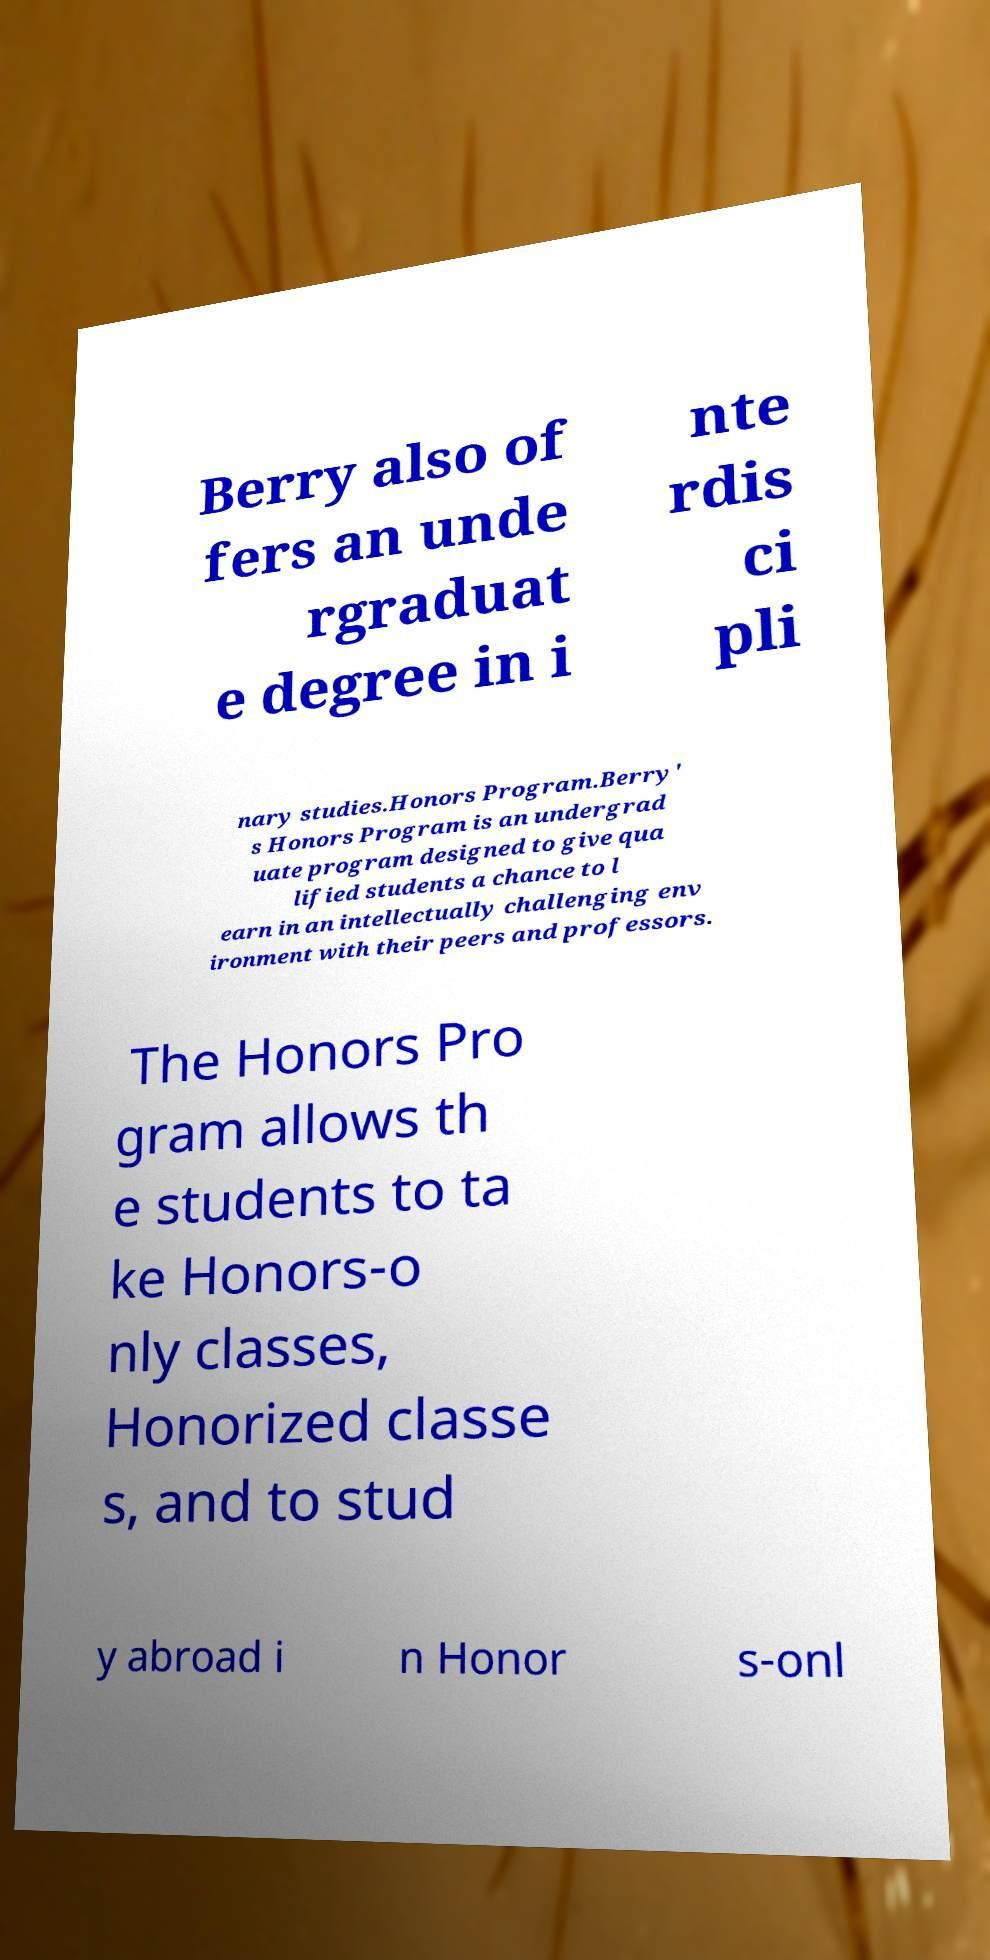Could you extract and type out the text from this image? Berry also of fers an unde rgraduat e degree in i nte rdis ci pli nary studies.Honors Program.Berry' s Honors Program is an undergrad uate program designed to give qua lified students a chance to l earn in an intellectually challenging env ironment with their peers and professors. The Honors Pro gram allows th e students to ta ke Honors-o nly classes, Honorized classe s, and to stud y abroad i n Honor s-onl 